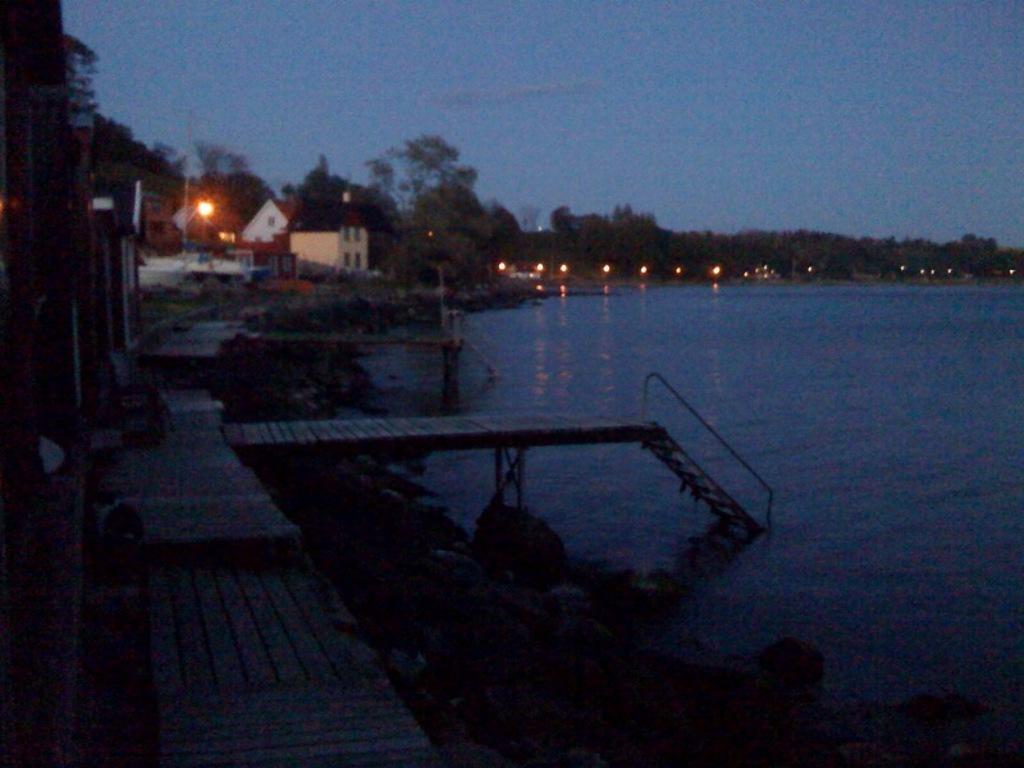In one or two sentences, can you explain what this image depicts? On the right there is a water body. On the left there are trailing, plants and dock. In the center of the picture there are houses, trees, lights and other objects. 